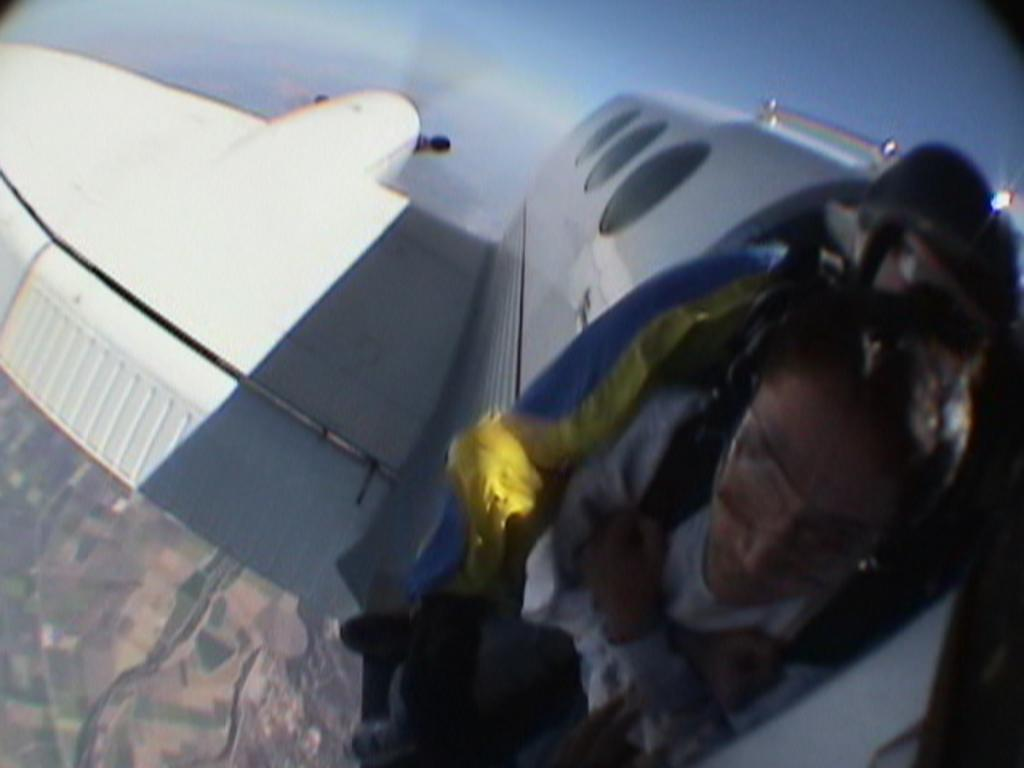What is the main subject of the image? The main subject of the image is an aircraft. What is the aircraft doing in the image? The aircraft is flying in the air. Can you describe the person inside the aircraft? There is a person in the aircraft, but their specific appearance or actions are not visible in the image. What can be seen in the background of the image? The ground and the sky are visible in the background of the image. How many grains of sand can be seen on the aircraft's wing in the image? There is no sand visible on the aircraft's wing in the image. Can you describe the person kicking a ball in the image? There is no person kicking a ball in the image; the main subject is an aircraft flying in the air. 